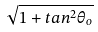Convert formula to latex. <formula><loc_0><loc_0><loc_500><loc_500>\sqrt { 1 + t a n ^ { 2 } \theta _ { o } }</formula> 